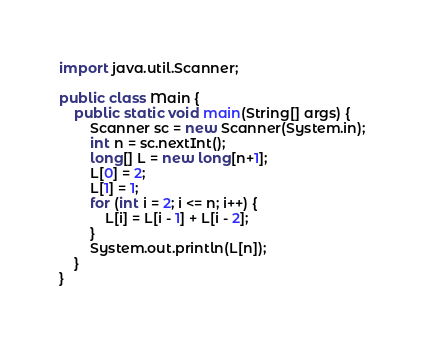Convert code to text. <code><loc_0><loc_0><loc_500><loc_500><_Java_>import java.util.Scanner;

public class Main {
	public static void main(String[] args) {
		Scanner sc = new Scanner(System.in);
		int n = sc.nextInt();
		long[] L = new long[n+1];
		L[0] = 2;
		L[1] = 1;
		for (int i = 2; i <= n; i++) {
			L[i] = L[i - 1] + L[i - 2];
		}
		System.out.println(L[n]);
	}
}
</code> 